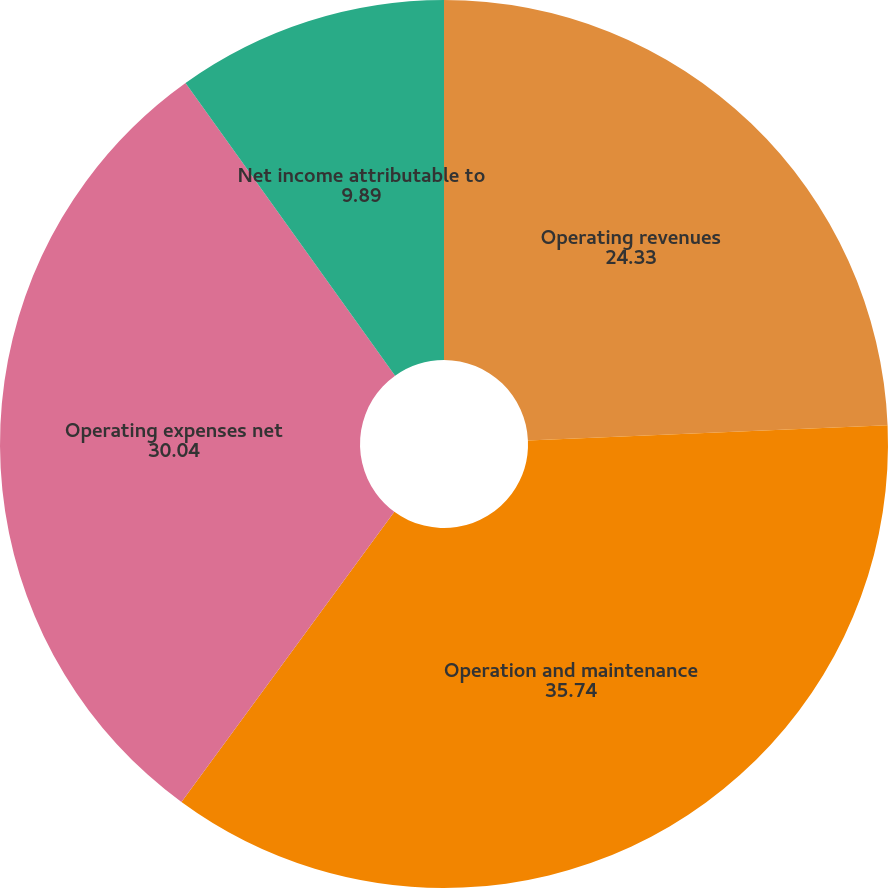Convert chart to OTSL. <chart><loc_0><loc_0><loc_500><loc_500><pie_chart><fcel>Operating revenues<fcel>Operation and maintenance<fcel>Operating expenses net<fcel>Net income attributable to<nl><fcel>24.33%<fcel>35.74%<fcel>30.04%<fcel>9.89%<nl></chart> 